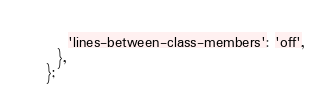Convert code to text. <code><loc_0><loc_0><loc_500><loc_500><_JavaScript_>    'lines-between-class-members': 'off',
  },
};
</code> 